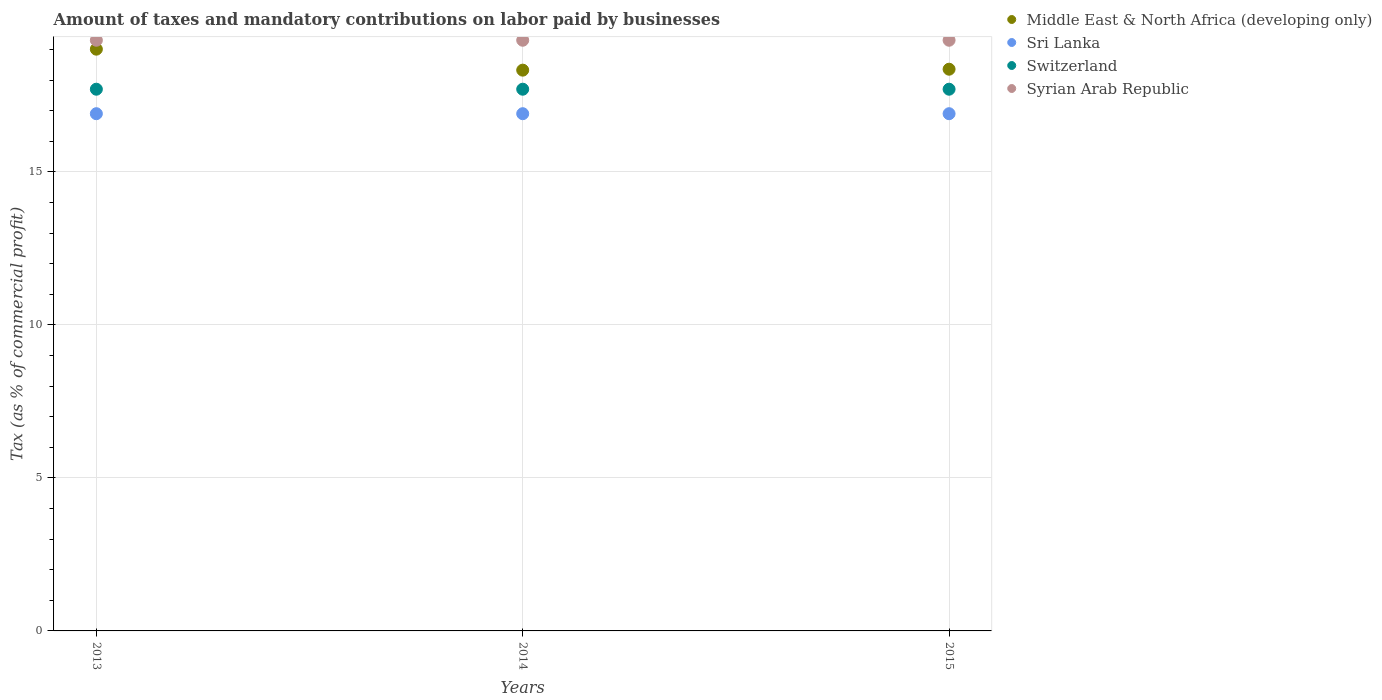How many different coloured dotlines are there?
Your answer should be very brief. 4. What is the percentage of taxes paid by businesses in Switzerland in 2014?
Your answer should be very brief. 17.7. Across all years, what is the maximum percentage of taxes paid by businesses in Sri Lanka?
Your answer should be compact. 16.9. In which year was the percentage of taxes paid by businesses in Sri Lanka maximum?
Offer a terse response. 2013. In which year was the percentage of taxes paid by businesses in Sri Lanka minimum?
Keep it short and to the point. 2013. What is the total percentage of taxes paid by businesses in Middle East & North Africa (developing only) in the graph?
Your response must be concise. 55.69. What is the difference between the percentage of taxes paid by businesses in Sri Lanka in 2013 and the percentage of taxes paid by businesses in Middle East & North Africa (developing only) in 2014?
Your answer should be compact. -1.42. What is the average percentage of taxes paid by businesses in Syrian Arab Republic per year?
Offer a terse response. 19.3. In the year 2014, what is the difference between the percentage of taxes paid by businesses in Switzerland and percentage of taxes paid by businesses in Middle East & North Africa (developing only)?
Provide a succinct answer. -0.62. What is the difference between the highest and the second highest percentage of taxes paid by businesses in Syrian Arab Republic?
Offer a terse response. 0. In how many years, is the percentage of taxes paid by businesses in Sri Lanka greater than the average percentage of taxes paid by businesses in Sri Lanka taken over all years?
Ensure brevity in your answer.  0. Is the sum of the percentage of taxes paid by businesses in Syrian Arab Republic in 2014 and 2015 greater than the maximum percentage of taxes paid by businesses in Switzerland across all years?
Provide a succinct answer. Yes. Does the percentage of taxes paid by businesses in Switzerland monotonically increase over the years?
Your answer should be compact. No. How many years are there in the graph?
Ensure brevity in your answer.  3. What is the difference between two consecutive major ticks on the Y-axis?
Offer a very short reply. 5. Are the values on the major ticks of Y-axis written in scientific E-notation?
Your answer should be very brief. No. Does the graph contain any zero values?
Your answer should be very brief. No. How many legend labels are there?
Keep it short and to the point. 4. What is the title of the graph?
Your response must be concise. Amount of taxes and mandatory contributions on labor paid by businesses. What is the label or title of the Y-axis?
Ensure brevity in your answer.  Tax (as % of commercial profit). What is the Tax (as % of commercial profit) of Middle East & North Africa (developing only) in 2013?
Your response must be concise. 19.01. What is the Tax (as % of commercial profit) of Switzerland in 2013?
Offer a very short reply. 17.7. What is the Tax (as % of commercial profit) of Syrian Arab Republic in 2013?
Keep it short and to the point. 19.3. What is the Tax (as % of commercial profit) in Middle East & North Africa (developing only) in 2014?
Offer a terse response. 18.32. What is the Tax (as % of commercial profit) in Switzerland in 2014?
Ensure brevity in your answer.  17.7. What is the Tax (as % of commercial profit) of Syrian Arab Republic in 2014?
Keep it short and to the point. 19.3. What is the Tax (as % of commercial profit) in Middle East & North Africa (developing only) in 2015?
Give a very brief answer. 18.35. What is the Tax (as % of commercial profit) in Syrian Arab Republic in 2015?
Your answer should be compact. 19.3. Across all years, what is the maximum Tax (as % of commercial profit) in Middle East & North Africa (developing only)?
Provide a short and direct response. 19.01. Across all years, what is the maximum Tax (as % of commercial profit) in Syrian Arab Republic?
Make the answer very short. 19.3. Across all years, what is the minimum Tax (as % of commercial profit) in Middle East & North Africa (developing only)?
Ensure brevity in your answer.  18.32. Across all years, what is the minimum Tax (as % of commercial profit) in Switzerland?
Your answer should be compact. 17.7. Across all years, what is the minimum Tax (as % of commercial profit) in Syrian Arab Republic?
Ensure brevity in your answer.  19.3. What is the total Tax (as % of commercial profit) in Middle East & North Africa (developing only) in the graph?
Your answer should be very brief. 55.69. What is the total Tax (as % of commercial profit) of Sri Lanka in the graph?
Provide a short and direct response. 50.7. What is the total Tax (as % of commercial profit) of Switzerland in the graph?
Provide a short and direct response. 53.1. What is the total Tax (as % of commercial profit) of Syrian Arab Republic in the graph?
Make the answer very short. 57.9. What is the difference between the Tax (as % of commercial profit) in Middle East & North Africa (developing only) in 2013 and that in 2014?
Give a very brief answer. 0.69. What is the difference between the Tax (as % of commercial profit) in Switzerland in 2013 and that in 2014?
Your answer should be very brief. 0. What is the difference between the Tax (as % of commercial profit) of Syrian Arab Republic in 2013 and that in 2014?
Make the answer very short. 0. What is the difference between the Tax (as % of commercial profit) in Middle East & North Africa (developing only) in 2013 and that in 2015?
Make the answer very short. 0.65. What is the difference between the Tax (as % of commercial profit) of Syrian Arab Republic in 2013 and that in 2015?
Offer a very short reply. 0. What is the difference between the Tax (as % of commercial profit) in Middle East & North Africa (developing only) in 2014 and that in 2015?
Provide a succinct answer. -0.03. What is the difference between the Tax (as % of commercial profit) in Switzerland in 2014 and that in 2015?
Offer a terse response. 0. What is the difference between the Tax (as % of commercial profit) in Middle East & North Africa (developing only) in 2013 and the Tax (as % of commercial profit) in Sri Lanka in 2014?
Keep it short and to the point. 2.11. What is the difference between the Tax (as % of commercial profit) in Middle East & North Africa (developing only) in 2013 and the Tax (as % of commercial profit) in Switzerland in 2014?
Ensure brevity in your answer.  1.31. What is the difference between the Tax (as % of commercial profit) in Middle East & North Africa (developing only) in 2013 and the Tax (as % of commercial profit) in Syrian Arab Republic in 2014?
Offer a terse response. -0.29. What is the difference between the Tax (as % of commercial profit) of Middle East & North Africa (developing only) in 2013 and the Tax (as % of commercial profit) of Sri Lanka in 2015?
Keep it short and to the point. 2.11. What is the difference between the Tax (as % of commercial profit) in Middle East & North Africa (developing only) in 2013 and the Tax (as % of commercial profit) in Switzerland in 2015?
Your answer should be very brief. 1.31. What is the difference between the Tax (as % of commercial profit) in Middle East & North Africa (developing only) in 2013 and the Tax (as % of commercial profit) in Syrian Arab Republic in 2015?
Your response must be concise. -0.29. What is the difference between the Tax (as % of commercial profit) of Switzerland in 2013 and the Tax (as % of commercial profit) of Syrian Arab Republic in 2015?
Offer a very short reply. -1.6. What is the difference between the Tax (as % of commercial profit) in Middle East & North Africa (developing only) in 2014 and the Tax (as % of commercial profit) in Sri Lanka in 2015?
Give a very brief answer. 1.42. What is the difference between the Tax (as % of commercial profit) in Middle East & North Africa (developing only) in 2014 and the Tax (as % of commercial profit) in Switzerland in 2015?
Your answer should be compact. 0.62. What is the difference between the Tax (as % of commercial profit) of Middle East & North Africa (developing only) in 2014 and the Tax (as % of commercial profit) of Syrian Arab Republic in 2015?
Offer a terse response. -0.98. What is the difference between the Tax (as % of commercial profit) of Switzerland in 2014 and the Tax (as % of commercial profit) of Syrian Arab Republic in 2015?
Provide a succinct answer. -1.6. What is the average Tax (as % of commercial profit) of Middle East & North Africa (developing only) per year?
Your response must be concise. 18.56. What is the average Tax (as % of commercial profit) in Sri Lanka per year?
Offer a terse response. 16.9. What is the average Tax (as % of commercial profit) of Switzerland per year?
Offer a terse response. 17.7. What is the average Tax (as % of commercial profit) of Syrian Arab Republic per year?
Offer a terse response. 19.3. In the year 2013, what is the difference between the Tax (as % of commercial profit) in Middle East & North Africa (developing only) and Tax (as % of commercial profit) in Sri Lanka?
Give a very brief answer. 2.11. In the year 2013, what is the difference between the Tax (as % of commercial profit) of Middle East & North Africa (developing only) and Tax (as % of commercial profit) of Switzerland?
Your answer should be very brief. 1.31. In the year 2013, what is the difference between the Tax (as % of commercial profit) of Middle East & North Africa (developing only) and Tax (as % of commercial profit) of Syrian Arab Republic?
Your response must be concise. -0.29. In the year 2013, what is the difference between the Tax (as % of commercial profit) in Switzerland and Tax (as % of commercial profit) in Syrian Arab Republic?
Provide a succinct answer. -1.6. In the year 2014, what is the difference between the Tax (as % of commercial profit) of Middle East & North Africa (developing only) and Tax (as % of commercial profit) of Sri Lanka?
Your response must be concise. 1.42. In the year 2014, what is the difference between the Tax (as % of commercial profit) in Middle East & North Africa (developing only) and Tax (as % of commercial profit) in Switzerland?
Keep it short and to the point. 0.62. In the year 2014, what is the difference between the Tax (as % of commercial profit) in Middle East & North Africa (developing only) and Tax (as % of commercial profit) in Syrian Arab Republic?
Keep it short and to the point. -0.98. In the year 2014, what is the difference between the Tax (as % of commercial profit) of Sri Lanka and Tax (as % of commercial profit) of Syrian Arab Republic?
Ensure brevity in your answer.  -2.4. In the year 2015, what is the difference between the Tax (as % of commercial profit) in Middle East & North Africa (developing only) and Tax (as % of commercial profit) in Sri Lanka?
Your answer should be very brief. 1.45. In the year 2015, what is the difference between the Tax (as % of commercial profit) in Middle East & North Africa (developing only) and Tax (as % of commercial profit) in Switzerland?
Your answer should be very brief. 0.65. In the year 2015, what is the difference between the Tax (as % of commercial profit) in Middle East & North Africa (developing only) and Tax (as % of commercial profit) in Syrian Arab Republic?
Ensure brevity in your answer.  -0.95. In the year 2015, what is the difference between the Tax (as % of commercial profit) in Sri Lanka and Tax (as % of commercial profit) in Switzerland?
Give a very brief answer. -0.8. What is the ratio of the Tax (as % of commercial profit) in Middle East & North Africa (developing only) in 2013 to that in 2014?
Keep it short and to the point. 1.04. What is the ratio of the Tax (as % of commercial profit) in Switzerland in 2013 to that in 2014?
Your answer should be very brief. 1. What is the ratio of the Tax (as % of commercial profit) in Syrian Arab Republic in 2013 to that in 2014?
Provide a succinct answer. 1. What is the ratio of the Tax (as % of commercial profit) of Middle East & North Africa (developing only) in 2013 to that in 2015?
Your answer should be very brief. 1.04. What is the ratio of the Tax (as % of commercial profit) of Sri Lanka in 2013 to that in 2015?
Your response must be concise. 1. What is the ratio of the Tax (as % of commercial profit) of Switzerland in 2014 to that in 2015?
Make the answer very short. 1. What is the difference between the highest and the second highest Tax (as % of commercial profit) in Middle East & North Africa (developing only)?
Provide a succinct answer. 0.65. What is the difference between the highest and the second highest Tax (as % of commercial profit) of Sri Lanka?
Your answer should be compact. 0. What is the difference between the highest and the lowest Tax (as % of commercial profit) in Middle East & North Africa (developing only)?
Provide a succinct answer. 0.69. What is the difference between the highest and the lowest Tax (as % of commercial profit) of Syrian Arab Republic?
Your response must be concise. 0. 